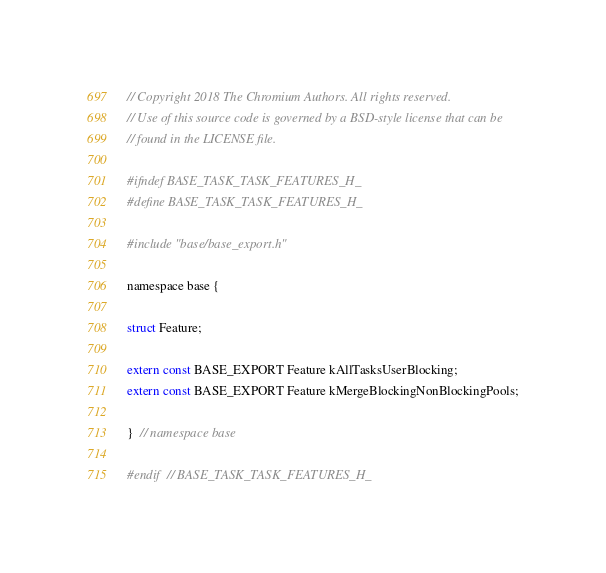<code> <loc_0><loc_0><loc_500><loc_500><_C_>// Copyright 2018 The Chromium Authors. All rights reserved.
// Use of this source code is governed by a BSD-style license that can be
// found in the LICENSE file.

#ifndef BASE_TASK_TASK_FEATURES_H_
#define BASE_TASK_TASK_FEATURES_H_

#include "base/base_export.h"

namespace base {

struct Feature;

extern const BASE_EXPORT Feature kAllTasksUserBlocking;
extern const BASE_EXPORT Feature kMergeBlockingNonBlockingPools;

}  // namespace base

#endif  // BASE_TASK_TASK_FEATURES_H_
</code> 